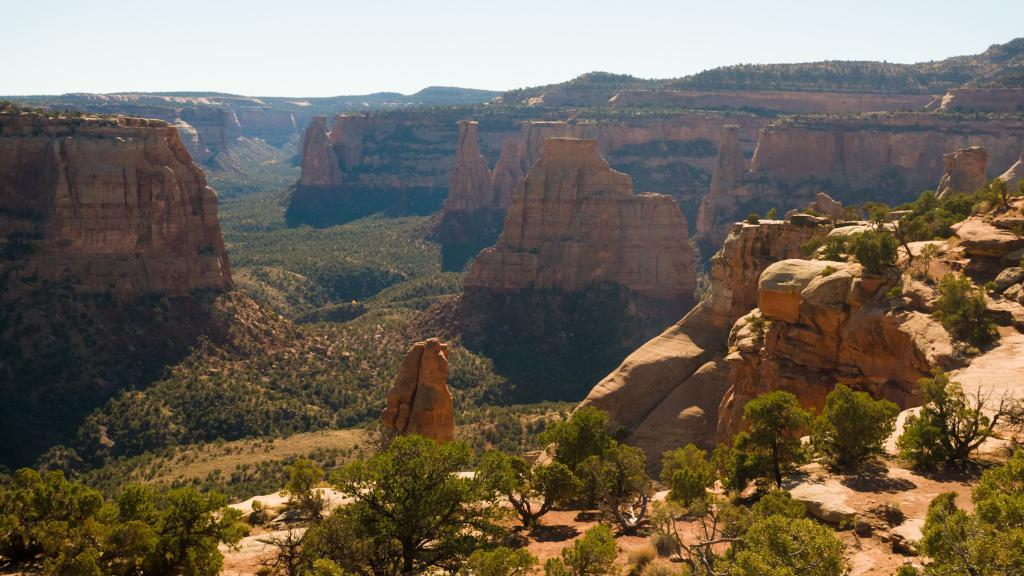What type of vegetation can be seen in the image? There are trees in the image. What geographical features are present in the image? There are hills in the image. How many cracks can be seen on the trees in the image? There is no mention of cracks on the trees in the image, so it cannot be determined from the provided facts. 